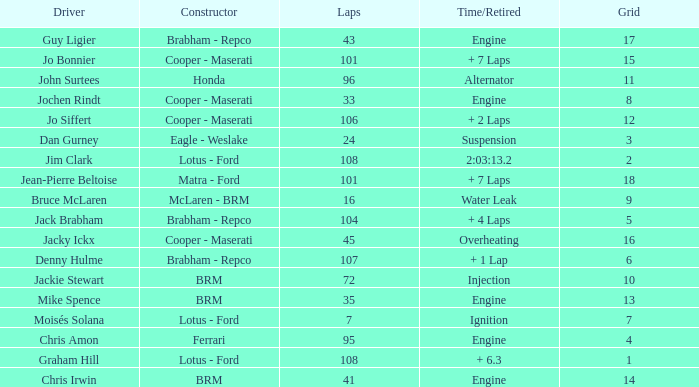What was the grid for suspension time/retired? 3.0. 